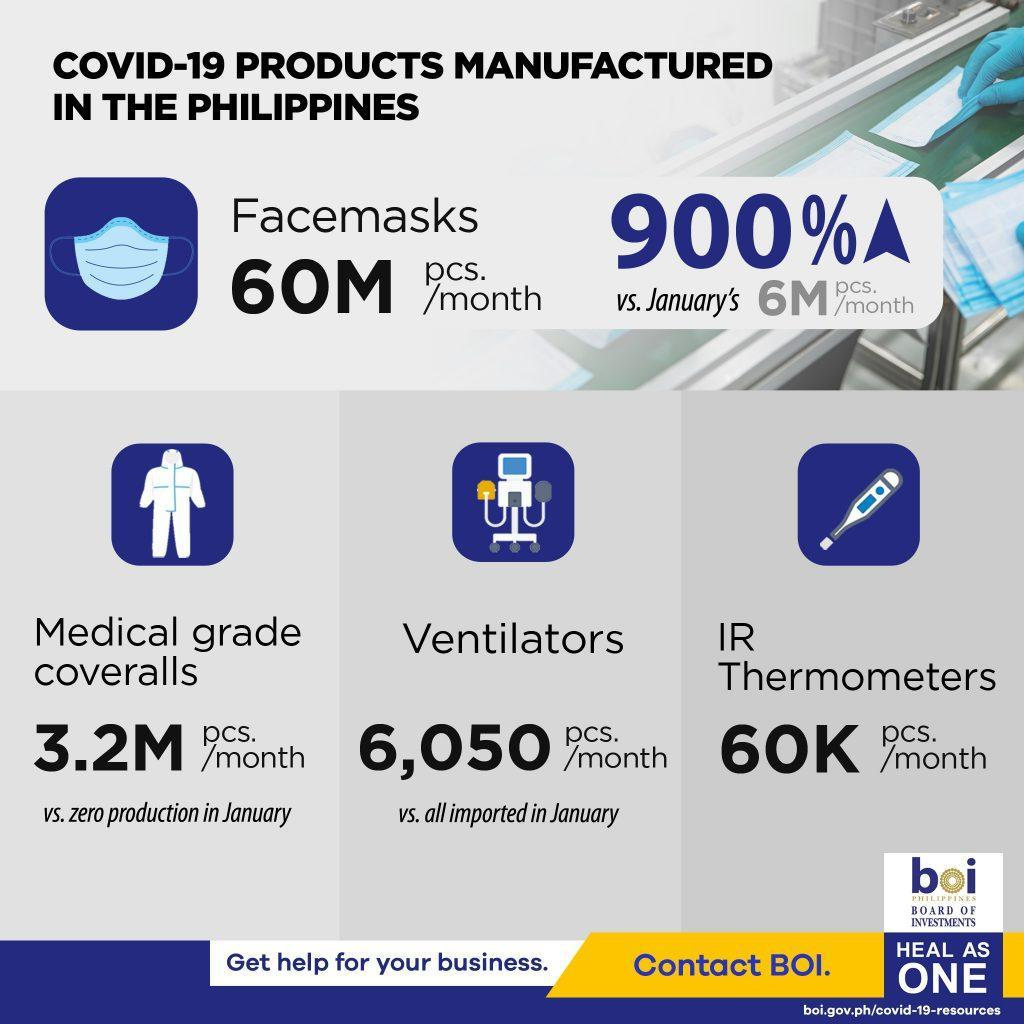How many ventilators are manufactured  per month in the Philippines due to the impact of COVID-19?
Answer the question with a short phrase. 6,050 pcs. How many IR thermometers are manufactured per month in the Philippines due to the impact of COVID-19? 60K pcs. What is the percentage increase in the production of face-masks in the Philippines due to the impact of COVID-19? 900% 